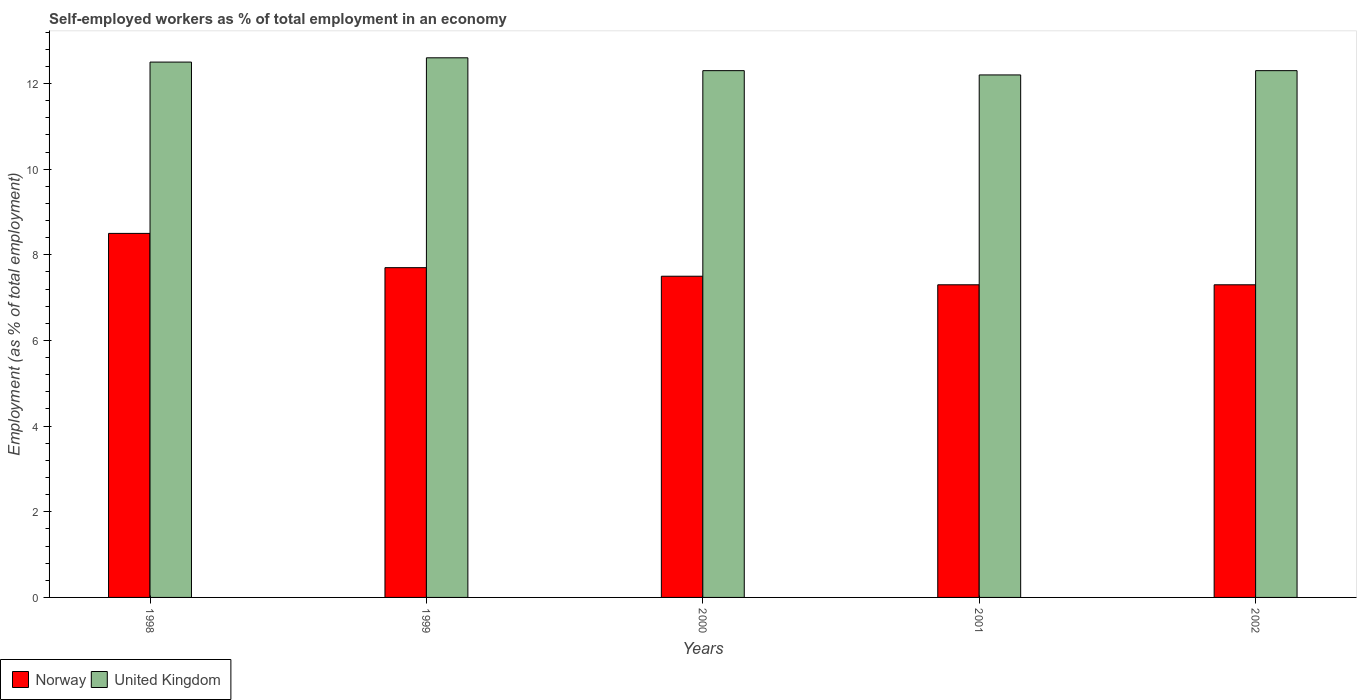How many different coloured bars are there?
Keep it short and to the point. 2. How many groups of bars are there?
Make the answer very short. 5. Are the number of bars per tick equal to the number of legend labels?
Provide a short and direct response. Yes. Are the number of bars on each tick of the X-axis equal?
Your answer should be compact. Yes. How many bars are there on the 3rd tick from the left?
Make the answer very short. 2. How many bars are there on the 2nd tick from the right?
Ensure brevity in your answer.  2. What is the percentage of self-employed workers in Norway in 1998?
Offer a terse response. 8.5. Across all years, what is the maximum percentage of self-employed workers in United Kingdom?
Ensure brevity in your answer.  12.6. Across all years, what is the minimum percentage of self-employed workers in Norway?
Your answer should be compact. 7.3. In which year was the percentage of self-employed workers in Norway maximum?
Offer a very short reply. 1998. In which year was the percentage of self-employed workers in United Kingdom minimum?
Give a very brief answer. 2001. What is the total percentage of self-employed workers in United Kingdom in the graph?
Your answer should be compact. 61.9. What is the difference between the percentage of self-employed workers in Norway in 2000 and that in 2002?
Provide a succinct answer. 0.2. What is the difference between the percentage of self-employed workers in United Kingdom in 2000 and the percentage of self-employed workers in Norway in 2002?
Offer a very short reply. 5. What is the average percentage of self-employed workers in Norway per year?
Ensure brevity in your answer.  7.66. What is the ratio of the percentage of self-employed workers in United Kingdom in 1999 to that in 2000?
Offer a terse response. 1.02. Is the percentage of self-employed workers in United Kingdom in 2001 less than that in 2002?
Keep it short and to the point. Yes. What is the difference between the highest and the second highest percentage of self-employed workers in Norway?
Offer a terse response. 0.8. What is the difference between the highest and the lowest percentage of self-employed workers in Norway?
Your response must be concise. 1.2. What does the 2nd bar from the left in 2001 represents?
Offer a terse response. United Kingdom. How many bars are there?
Give a very brief answer. 10. What is the difference between two consecutive major ticks on the Y-axis?
Provide a short and direct response. 2. Are the values on the major ticks of Y-axis written in scientific E-notation?
Give a very brief answer. No. Does the graph contain any zero values?
Ensure brevity in your answer.  No. Does the graph contain grids?
Give a very brief answer. No. Where does the legend appear in the graph?
Give a very brief answer. Bottom left. How are the legend labels stacked?
Offer a very short reply. Horizontal. What is the title of the graph?
Ensure brevity in your answer.  Self-employed workers as % of total employment in an economy. Does "Argentina" appear as one of the legend labels in the graph?
Your answer should be very brief. No. What is the label or title of the X-axis?
Provide a succinct answer. Years. What is the label or title of the Y-axis?
Your response must be concise. Employment (as % of total employment). What is the Employment (as % of total employment) of Norway in 1999?
Give a very brief answer. 7.7. What is the Employment (as % of total employment) in United Kingdom in 1999?
Provide a short and direct response. 12.6. What is the Employment (as % of total employment) in United Kingdom in 2000?
Your response must be concise. 12.3. What is the Employment (as % of total employment) of Norway in 2001?
Give a very brief answer. 7.3. What is the Employment (as % of total employment) in United Kingdom in 2001?
Offer a very short reply. 12.2. What is the Employment (as % of total employment) in Norway in 2002?
Keep it short and to the point. 7.3. What is the Employment (as % of total employment) in United Kingdom in 2002?
Make the answer very short. 12.3. Across all years, what is the maximum Employment (as % of total employment) in Norway?
Make the answer very short. 8.5. Across all years, what is the maximum Employment (as % of total employment) in United Kingdom?
Your response must be concise. 12.6. Across all years, what is the minimum Employment (as % of total employment) in Norway?
Provide a succinct answer. 7.3. Across all years, what is the minimum Employment (as % of total employment) of United Kingdom?
Offer a terse response. 12.2. What is the total Employment (as % of total employment) of Norway in the graph?
Give a very brief answer. 38.3. What is the total Employment (as % of total employment) of United Kingdom in the graph?
Ensure brevity in your answer.  61.9. What is the difference between the Employment (as % of total employment) in Norway in 1998 and that in 1999?
Offer a terse response. 0.8. What is the difference between the Employment (as % of total employment) of United Kingdom in 1998 and that in 1999?
Give a very brief answer. -0.1. What is the difference between the Employment (as % of total employment) of Norway in 1998 and that in 2000?
Your response must be concise. 1. What is the difference between the Employment (as % of total employment) of Norway in 1998 and that in 2001?
Your response must be concise. 1.2. What is the difference between the Employment (as % of total employment) of Norway in 1998 and that in 2002?
Offer a very short reply. 1.2. What is the difference between the Employment (as % of total employment) of Norway in 1999 and that in 2000?
Offer a terse response. 0.2. What is the difference between the Employment (as % of total employment) of Norway in 1999 and that in 2001?
Your answer should be compact. 0.4. What is the difference between the Employment (as % of total employment) in United Kingdom in 1999 and that in 2001?
Offer a very short reply. 0.4. What is the difference between the Employment (as % of total employment) of Norway in 1999 and that in 2002?
Your response must be concise. 0.4. What is the difference between the Employment (as % of total employment) of Norway in 2000 and that in 2001?
Keep it short and to the point. 0.2. What is the difference between the Employment (as % of total employment) of United Kingdom in 2000 and that in 2001?
Your response must be concise. 0.1. What is the difference between the Employment (as % of total employment) of Norway in 2000 and that in 2002?
Your response must be concise. 0.2. What is the difference between the Employment (as % of total employment) of United Kingdom in 2000 and that in 2002?
Your response must be concise. 0. What is the difference between the Employment (as % of total employment) in Norway in 1998 and the Employment (as % of total employment) in United Kingdom in 2000?
Provide a succinct answer. -3.8. What is the difference between the Employment (as % of total employment) of Norway in 1998 and the Employment (as % of total employment) of United Kingdom in 2002?
Make the answer very short. -3.8. What is the difference between the Employment (as % of total employment) in Norway in 1999 and the Employment (as % of total employment) in United Kingdom in 2001?
Your answer should be compact. -4.5. What is the difference between the Employment (as % of total employment) of Norway in 2000 and the Employment (as % of total employment) of United Kingdom in 2001?
Ensure brevity in your answer.  -4.7. What is the difference between the Employment (as % of total employment) in Norway in 2000 and the Employment (as % of total employment) in United Kingdom in 2002?
Offer a terse response. -4.8. What is the average Employment (as % of total employment) in Norway per year?
Provide a short and direct response. 7.66. What is the average Employment (as % of total employment) of United Kingdom per year?
Make the answer very short. 12.38. In the year 1998, what is the difference between the Employment (as % of total employment) of Norway and Employment (as % of total employment) of United Kingdom?
Offer a very short reply. -4. In the year 2002, what is the difference between the Employment (as % of total employment) in Norway and Employment (as % of total employment) in United Kingdom?
Give a very brief answer. -5. What is the ratio of the Employment (as % of total employment) of Norway in 1998 to that in 1999?
Offer a very short reply. 1.1. What is the ratio of the Employment (as % of total employment) of United Kingdom in 1998 to that in 1999?
Your answer should be compact. 0.99. What is the ratio of the Employment (as % of total employment) in Norway in 1998 to that in 2000?
Offer a very short reply. 1.13. What is the ratio of the Employment (as % of total employment) in United Kingdom in 1998 to that in 2000?
Ensure brevity in your answer.  1.02. What is the ratio of the Employment (as % of total employment) of Norway in 1998 to that in 2001?
Keep it short and to the point. 1.16. What is the ratio of the Employment (as % of total employment) of United Kingdom in 1998 to that in 2001?
Your answer should be compact. 1.02. What is the ratio of the Employment (as % of total employment) of Norway in 1998 to that in 2002?
Offer a terse response. 1.16. What is the ratio of the Employment (as % of total employment) in United Kingdom in 1998 to that in 2002?
Your answer should be very brief. 1.02. What is the ratio of the Employment (as % of total employment) in Norway in 1999 to that in 2000?
Give a very brief answer. 1.03. What is the ratio of the Employment (as % of total employment) of United Kingdom in 1999 to that in 2000?
Provide a short and direct response. 1.02. What is the ratio of the Employment (as % of total employment) in Norway in 1999 to that in 2001?
Give a very brief answer. 1.05. What is the ratio of the Employment (as % of total employment) of United Kingdom in 1999 to that in 2001?
Your response must be concise. 1.03. What is the ratio of the Employment (as % of total employment) of Norway in 1999 to that in 2002?
Give a very brief answer. 1.05. What is the ratio of the Employment (as % of total employment) in United Kingdom in 1999 to that in 2002?
Offer a terse response. 1.02. What is the ratio of the Employment (as % of total employment) of Norway in 2000 to that in 2001?
Your answer should be compact. 1.03. What is the ratio of the Employment (as % of total employment) in United Kingdom in 2000 to that in 2001?
Your answer should be compact. 1.01. What is the ratio of the Employment (as % of total employment) of Norway in 2000 to that in 2002?
Give a very brief answer. 1.03. What is the ratio of the Employment (as % of total employment) in United Kingdom in 2001 to that in 2002?
Ensure brevity in your answer.  0.99. What is the difference between the highest and the second highest Employment (as % of total employment) of Norway?
Give a very brief answer. 0.8. What is the difference between the highest and the second highest Employment (as % of total employment) in United Kingdom?
Offer a very short reply. 0.1. 